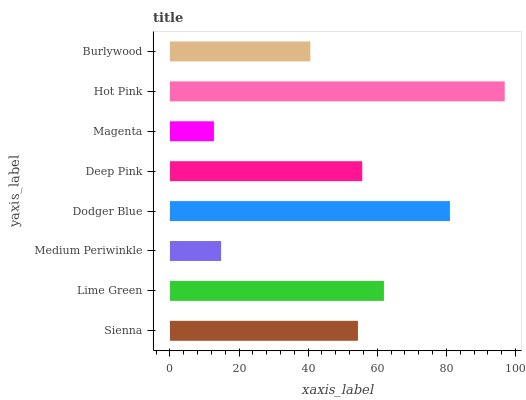Is Magenta the minimum?
Answer yes or no. Yes. Is Hot Pink the maximum?
Answer yes or no. Yes. Is Lime Green the minimum?
Answer yes or no. No. Is Lime Green the maximum?
Answer yes or no. No. Is Lime Green greater than Sienna?
Answer yes or no. Yes. Is Sienna less than Lime Green?
Answer yes or no. Yes. Is Sienna greater than Lime Green?
Answer yes or no. No. Is Lime Green less than Sienna?
Answer yes or no. No. Is Deep Pink the high median?
Answer yes or no. Yes. Is Sienna the low median?
Answer yes or no. Yes. Is Sienna the high median?
Answer yes or no. No. Is Hot Pink the low median?
Answer yes or no. No. 